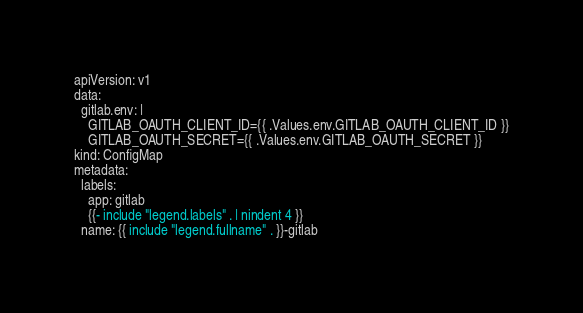Convert code to text. <code><loc_0><loc_0><loc_500><loc_500><_YAML_>apiVersion: v1
data:
  gitlab.env: |
    GITLAB_OAUTH_CLIENT_ID={{ .Values.env.GITLAB_OAUTH_CLIENT_ID }}
    GITLAB_OAUTH_SECRET={{ .Values.env.GITLAB_OAUTH_SECRET }}
kind: ConfigMap
metadata:
  labels:
    app: gitlab
    {{- include "legend.labels" . | nindent 4 }}
  name: {{ include "legend.fullname" . }}-gitlab</code> 